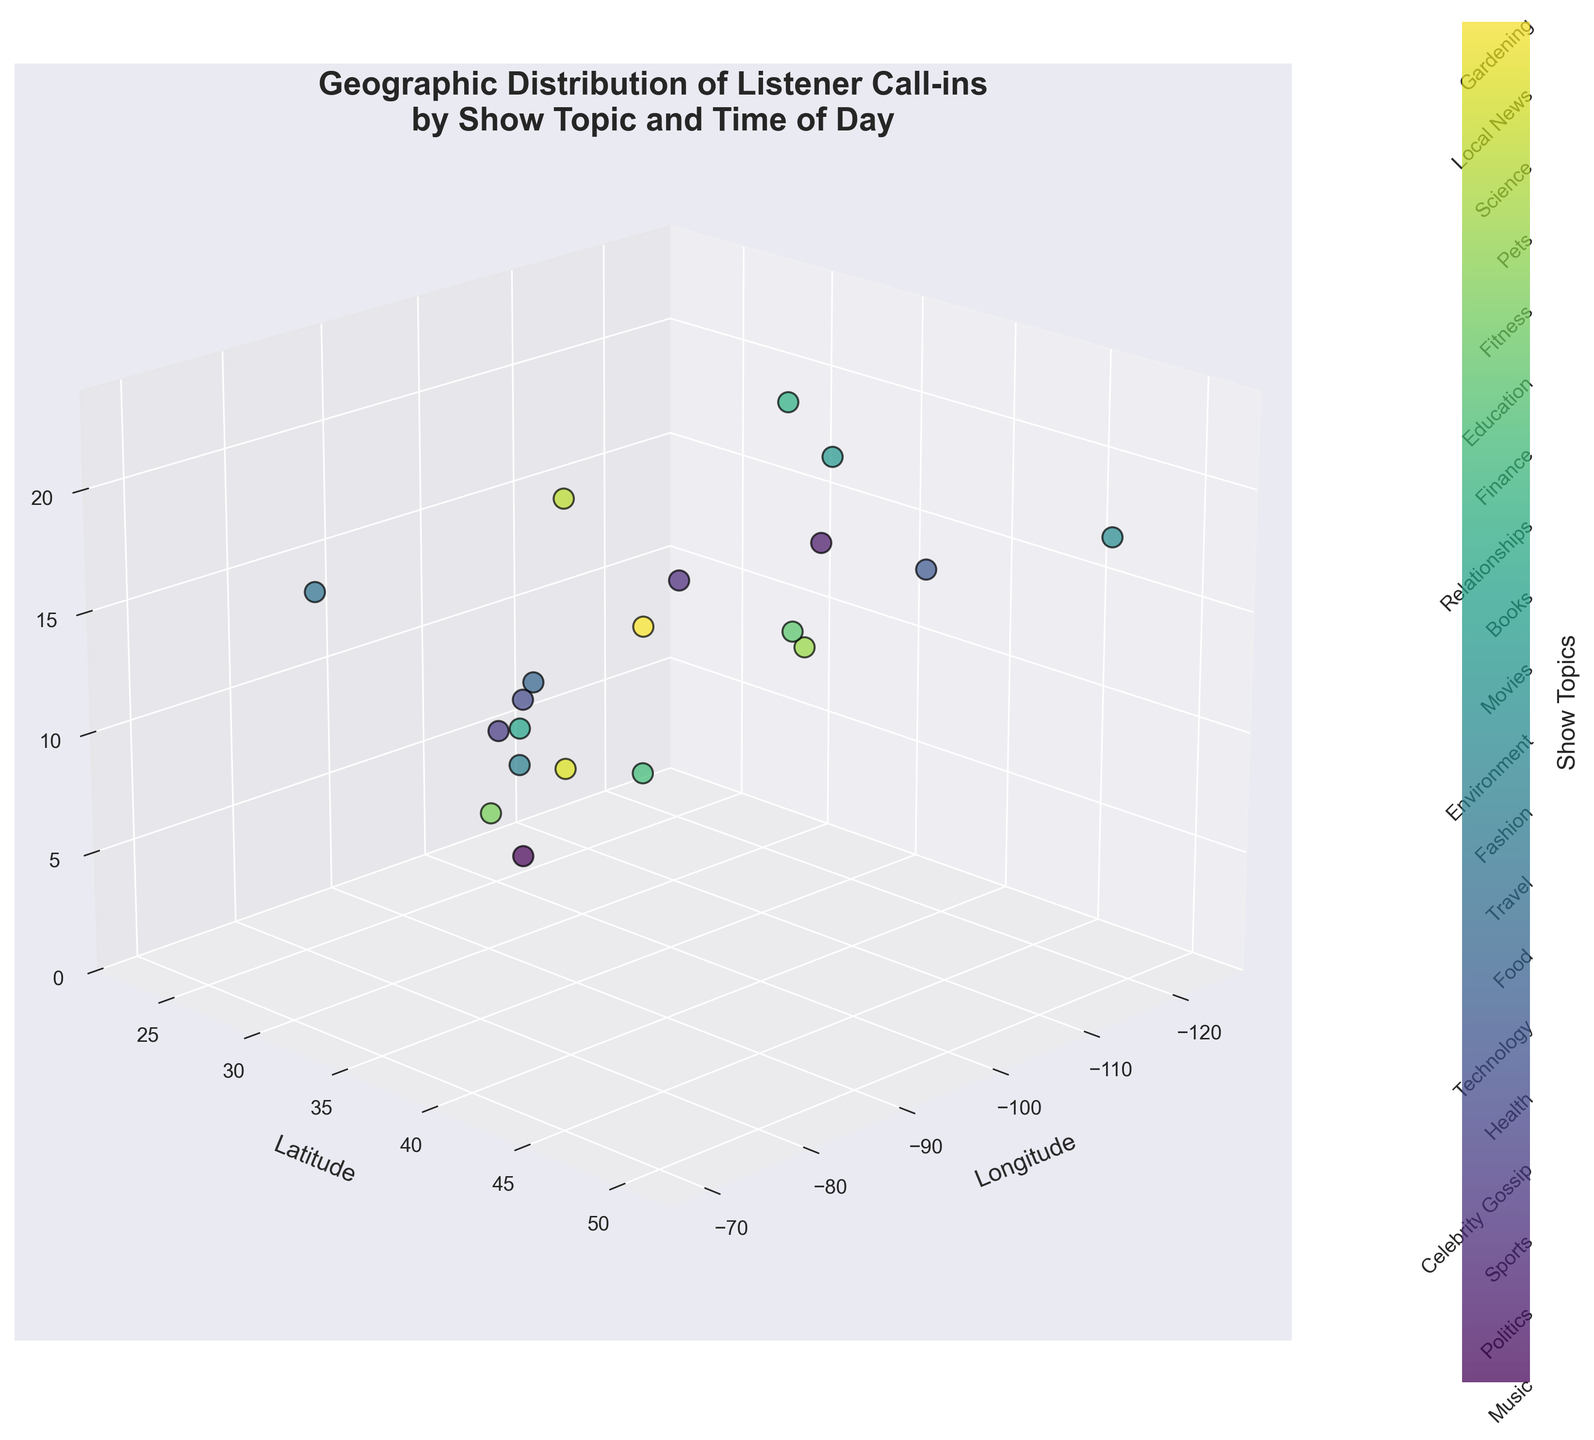How many topics of listener call-ins are represented in the figure? The color bar on the side of the scatter plot labels each unique show topic. Count the total number of tick marks or labels shown.
Answer: 20 Which topic has call-ins at the earliest time of day? On the z-axis (Time of Day), find the lowest point and look at the associated colors and labels on the scatter plot to identify the topic.
Answer: Fitness At what general time of the day do most call-ins occur? Inspect the scatter plot to see when the majority of the data points (represented by spheres) are clustered along the z-axis (Time of Day).
Answer: Afternoon Which city had a call-in related to Politics? Find the specific data point labeled as Politics by matching the color bar to the scatter plot, then check its corresponding Latitude and Longitude coordinates.
Answer: Los Angeles Compare the times of call-ins for Health and Education. Which one happens later? Locate the data points for Health and Education by matching the colors from the bar, then compare their positions along the z-axis (Time of Day).
Answer: Education What is the geographic span of call-ins from north to south? Check the y-axis (Latitude) of the scatter plot and note the highest and lowest points of the data points to determine the span.
Answer: Approximately 17.6 degrees Which topic had a call-in from the northeastern US and at what time? Examine the Latitude and Longitude coordinates in the scatter plot, focusing on higher latitudes and corresponding longitudes. Then, check the time associated with this data point.
Answer: Health, 16:20 Among Music, Sports, and Movies, which show had call-ins the closest in time? Identify the data points for Music, Sports, and Movies by matching colors, then compare their positions along the z-axis (Time).
Answer: Sports and Movies How does the distribution of call-ins differ geographically between Technology and Local News? Find the data points for Technology and Local News based on the color bar and compare their positions on the Latitude (y-axis) and Longitude (x-axis).
Answer: Technology is concentrated on the west coast; Local News is central What can you infer about the relationship between the show topic and call-in time from the scatter plot? Observe the color distribution along the z-axis (Time of Day) and note if certain topics tend to have call-ins at particular times of the day. This suggests potential patterns or preferences among listeners.
Answer: Varied; some topics like Fitness have early call-ins, while others like Relationships are later 